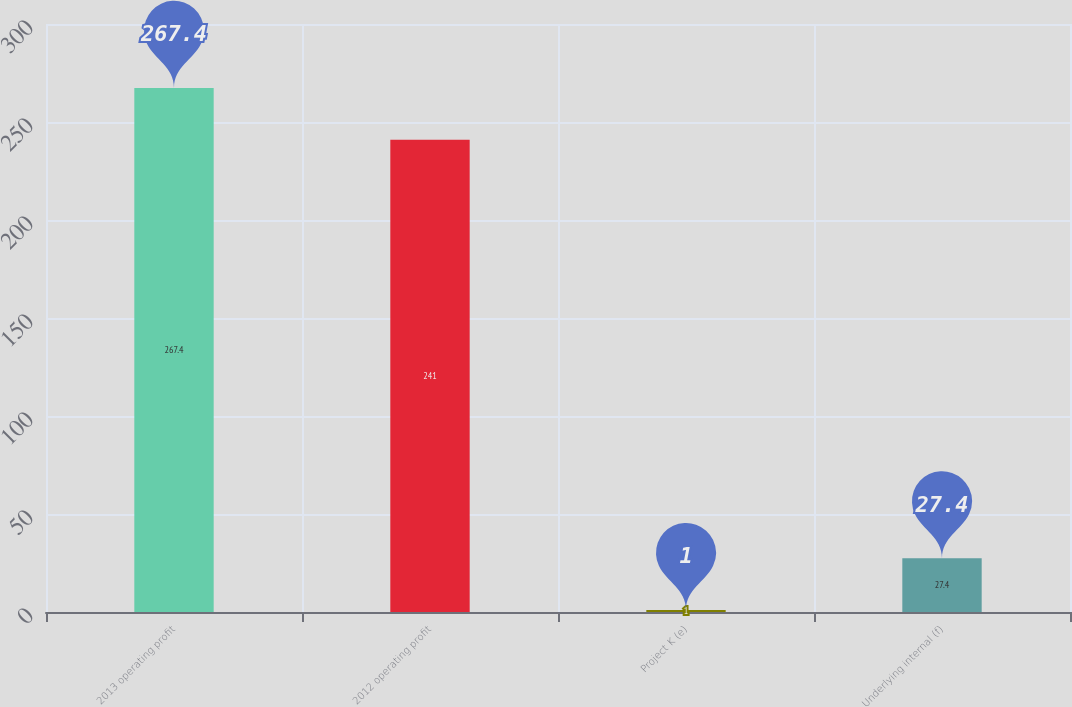Convert chart. <chart><loc_0><loc_0><loc_500><loc_500><bar_chart><fcel>2013 operating profit<fcel>2012 operating profit<fcel>Project K (e)<fcel>Underlying internal (f)<nl><fcel>267.4<fcel>241<fcel>1<fcel>27.4<nl></chart> 